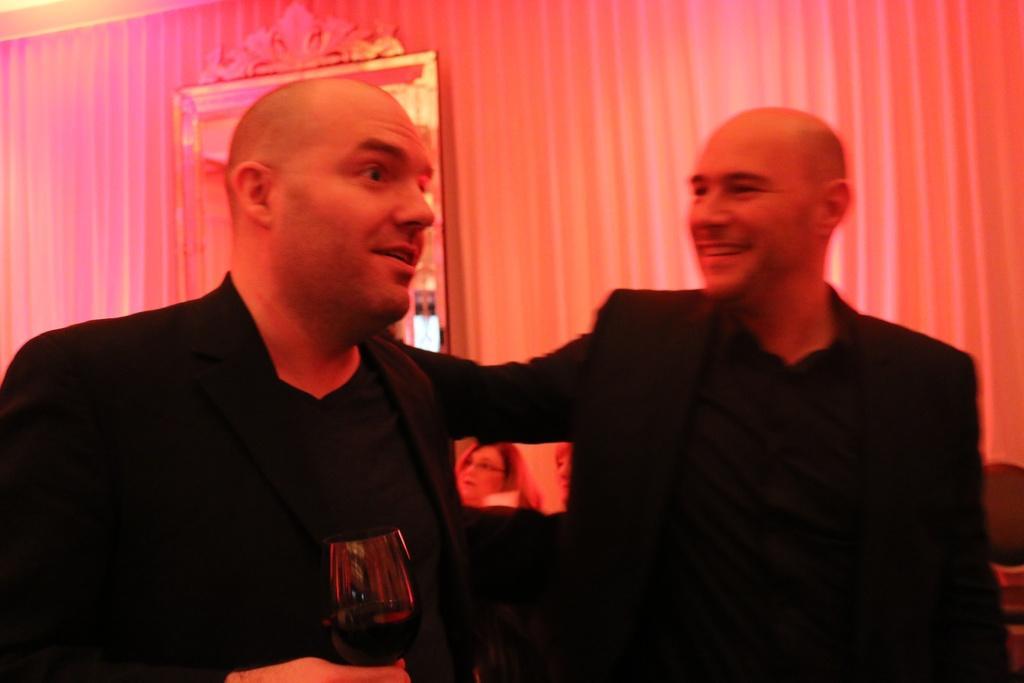Describe this image in one or two sentences. In this image there are two men in the middle. The man on the left side is holding the glass while the man on the right side is keeping his hand on the man who is beside him. In the background there is a mirror to the wall. 